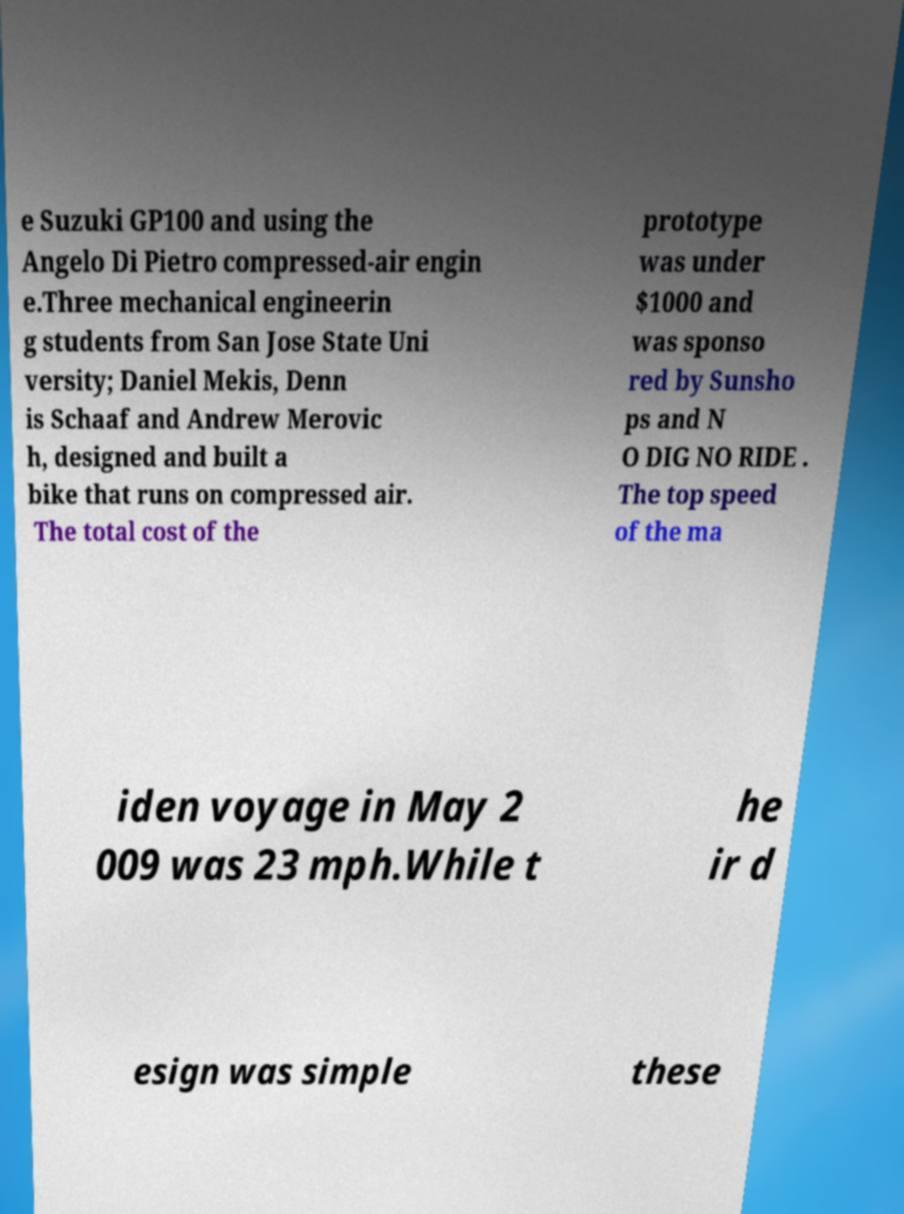Can you accurately transcribe the text from the provided image for me? e Suzuki GP100 and using the Angelo Di Pietro compressed-air engin e.Three mechanical engineerin g students from San Jose State Uni versity; Daniel Mekis, Denn is Schaaf and Andrew Merovic h, designed and built a bike that runs on compressed air. The total cost of the prototype was under $1000 and was sponso red by Sunsho ps and N O DIG NO RIDE . The top speed of the ma iden voyage in May 2 009 was 23 mph.While t he ir d esign was simple these 